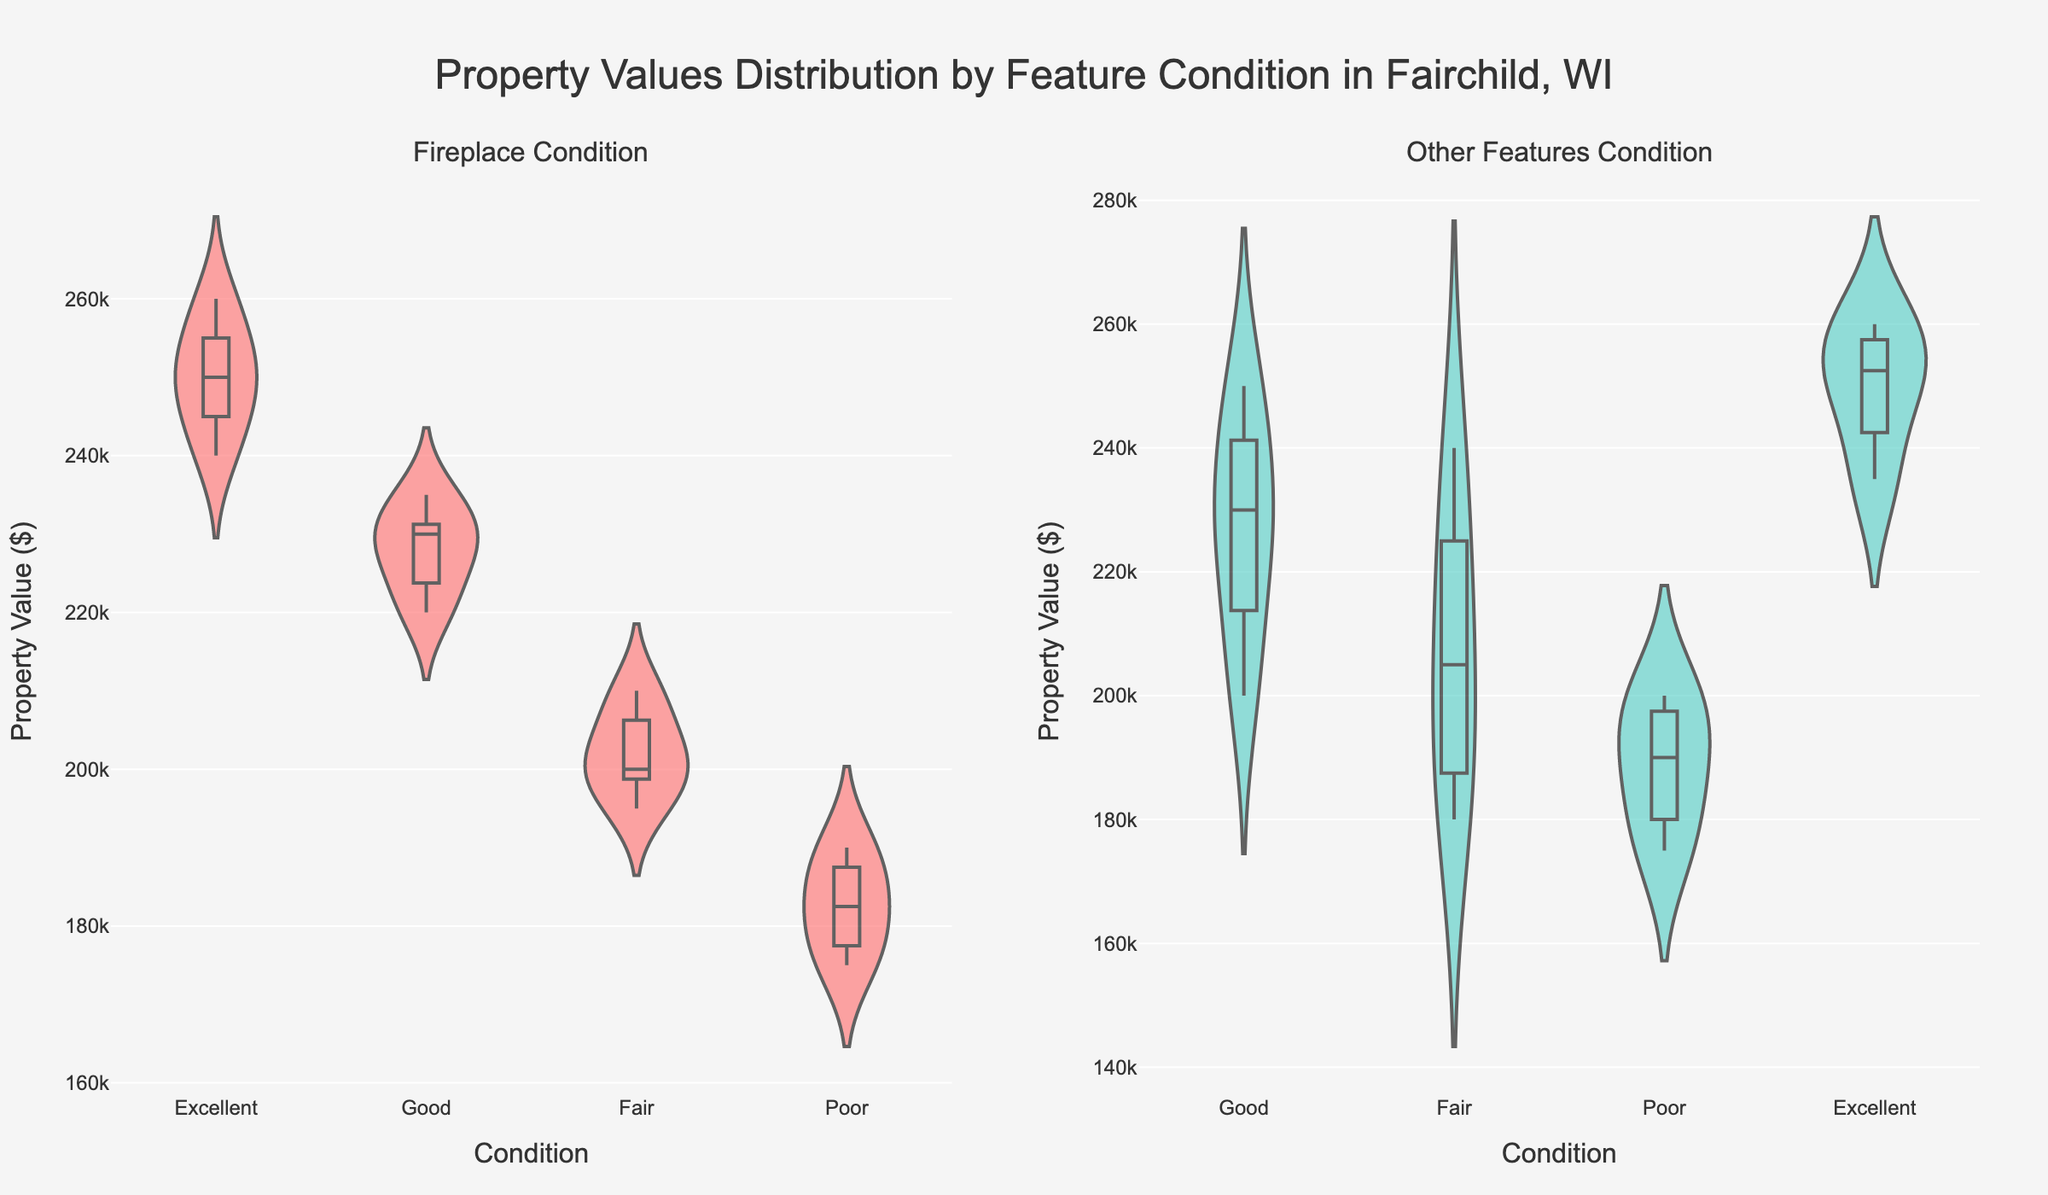What is the title of the figure? The title is located at the top center of the figure, clearly stating the subject of the chart.
Answer: Property Values Distribution by Feature Condition in Fairchild, WI How many different conditions are shown for the fireplaces? The 'Condition' axis under the 'Fireplace Condition' subplot shows the categories represented in the violin plot. All categories named are tallied.
Answer: 4 Which condition of fireplaces seems to have the highest property values? By examining the density and median line within the violin plot for fireplace condition, identify which one tends to have higher values.
Answer: Excellent Are property values more variable for fireplaces in Poor condition or Fair condition? Examine the spread (width and length) of the violin plots for properties with fireplaces in Poor and Fair conditions.
Answer: Fair Looking at the other features' condition, which condition usually corresponds with lower property values? By observing the violin plot for 'Other Features Condition,' identify the condition with the lower spread/distribution of values.
Answer: Poor How does the median property value compare between homes with Excellent fireplaces and Excellent other features? Medians are typically indicated by a dashed line within the violin plots. Compare the approximate positions of these lines in both subplots for 'Excellent' condition.
Answer: Approximately similar What can be said about the distribution of property values in homes with Good fireplaces? Review the shape of the violin plot for 'Good' fireplace condition, noting if it is wide (variable) or narrow (less variable) and centered around any value.
Answer: Fairly centered with some variability Which feature condition shows a more evenly distributed range of property values, fireplaces or other features? Compare the shapes and density patterns in both subplots to see which feature condition has a more even spread.
Answer: Other features Is there any instance where the property values overlap significantly between two conditions of the same feature? Identify if any two categories within either subplot have many overlapping property values, suggesting similar ranges.
Answer: Yes, for Good and Fair fireplaces Does it appear that having an Excellent fireplace or Excellent other features leads to higher property values? By focusing on the higher sections or densities of the violin plots for 'Excellent' condition in both subplots, determine if these generally correspond to higher property values.
Answer: Yes Which condition of other features shows the least variability in property values? Check for the narrowest violin plot among the different conditions of other features, indicating less variation in data points.
Answer: Excellent 